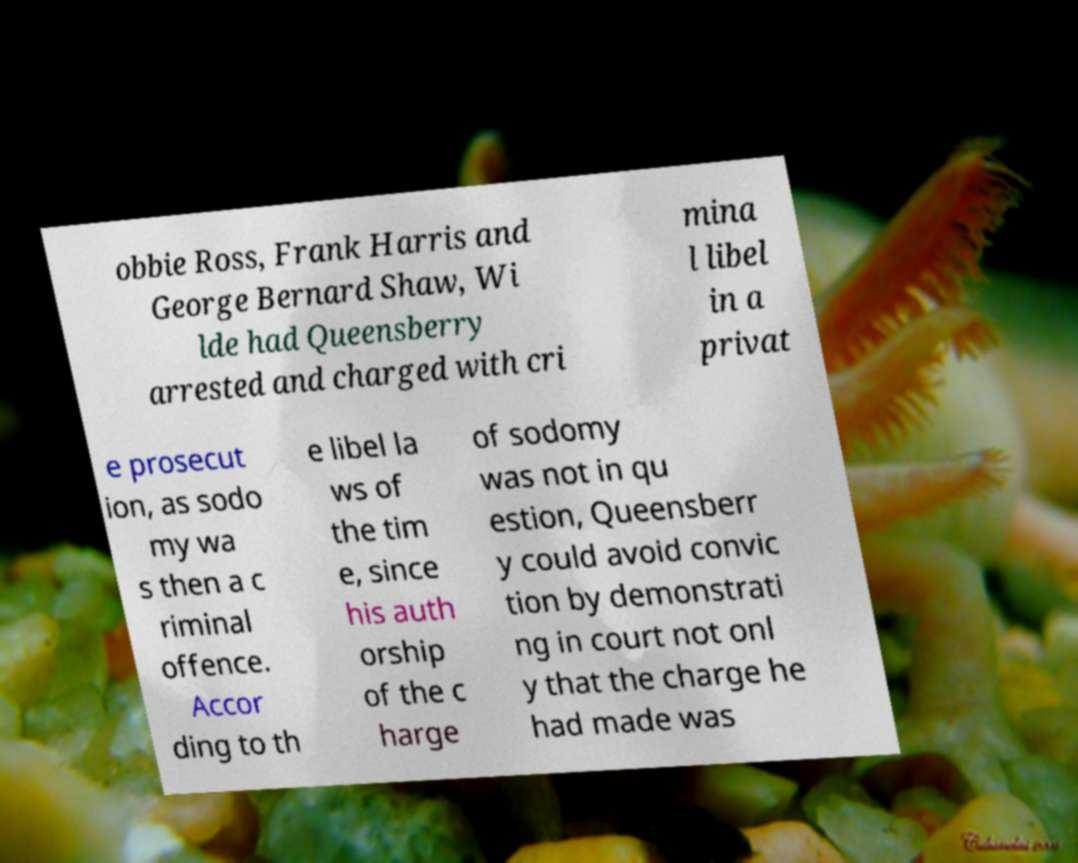For documentation purposes, I need the text within this image transcribed. Could you provide that? obbie Ross, Frank Harris and George Bernard Shaw, Wi lde had Queensberry arrested and charged with cri mina l libel in a privat e prosecut ion, as sodo my wa s then a c riminal offence. Accor ding to th e libel la ws of the tim e, since his auth orship of the c harge of sodomy was not in qu estion, Queensberr y could avoid convic tion by demonstrati ng in court not onl y that the charge he had made was 